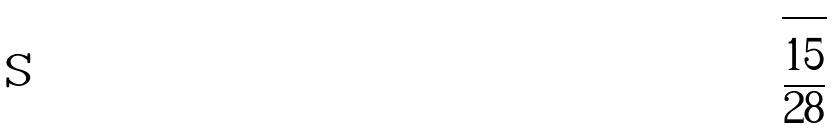Convert formula to latex. <formula><loc_0><loc_0><loc_500><loc_500>\sqrt { \frac { 1 5 } { 2 8 } }</formula> 